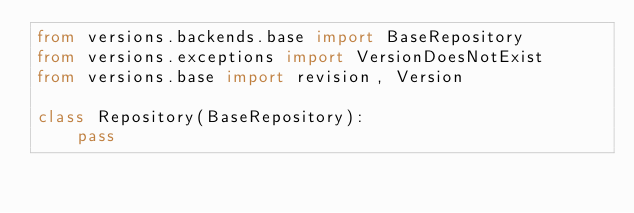<code> <loc_0><loc_0><loc_500><loc_500><_Python_>from versions.backends.base import BaseRepository
from versions.exceptions import VersionDoesNotExist
from versions.base import revision, Version

class Repository(BaseRepository):
    pass
</code> 